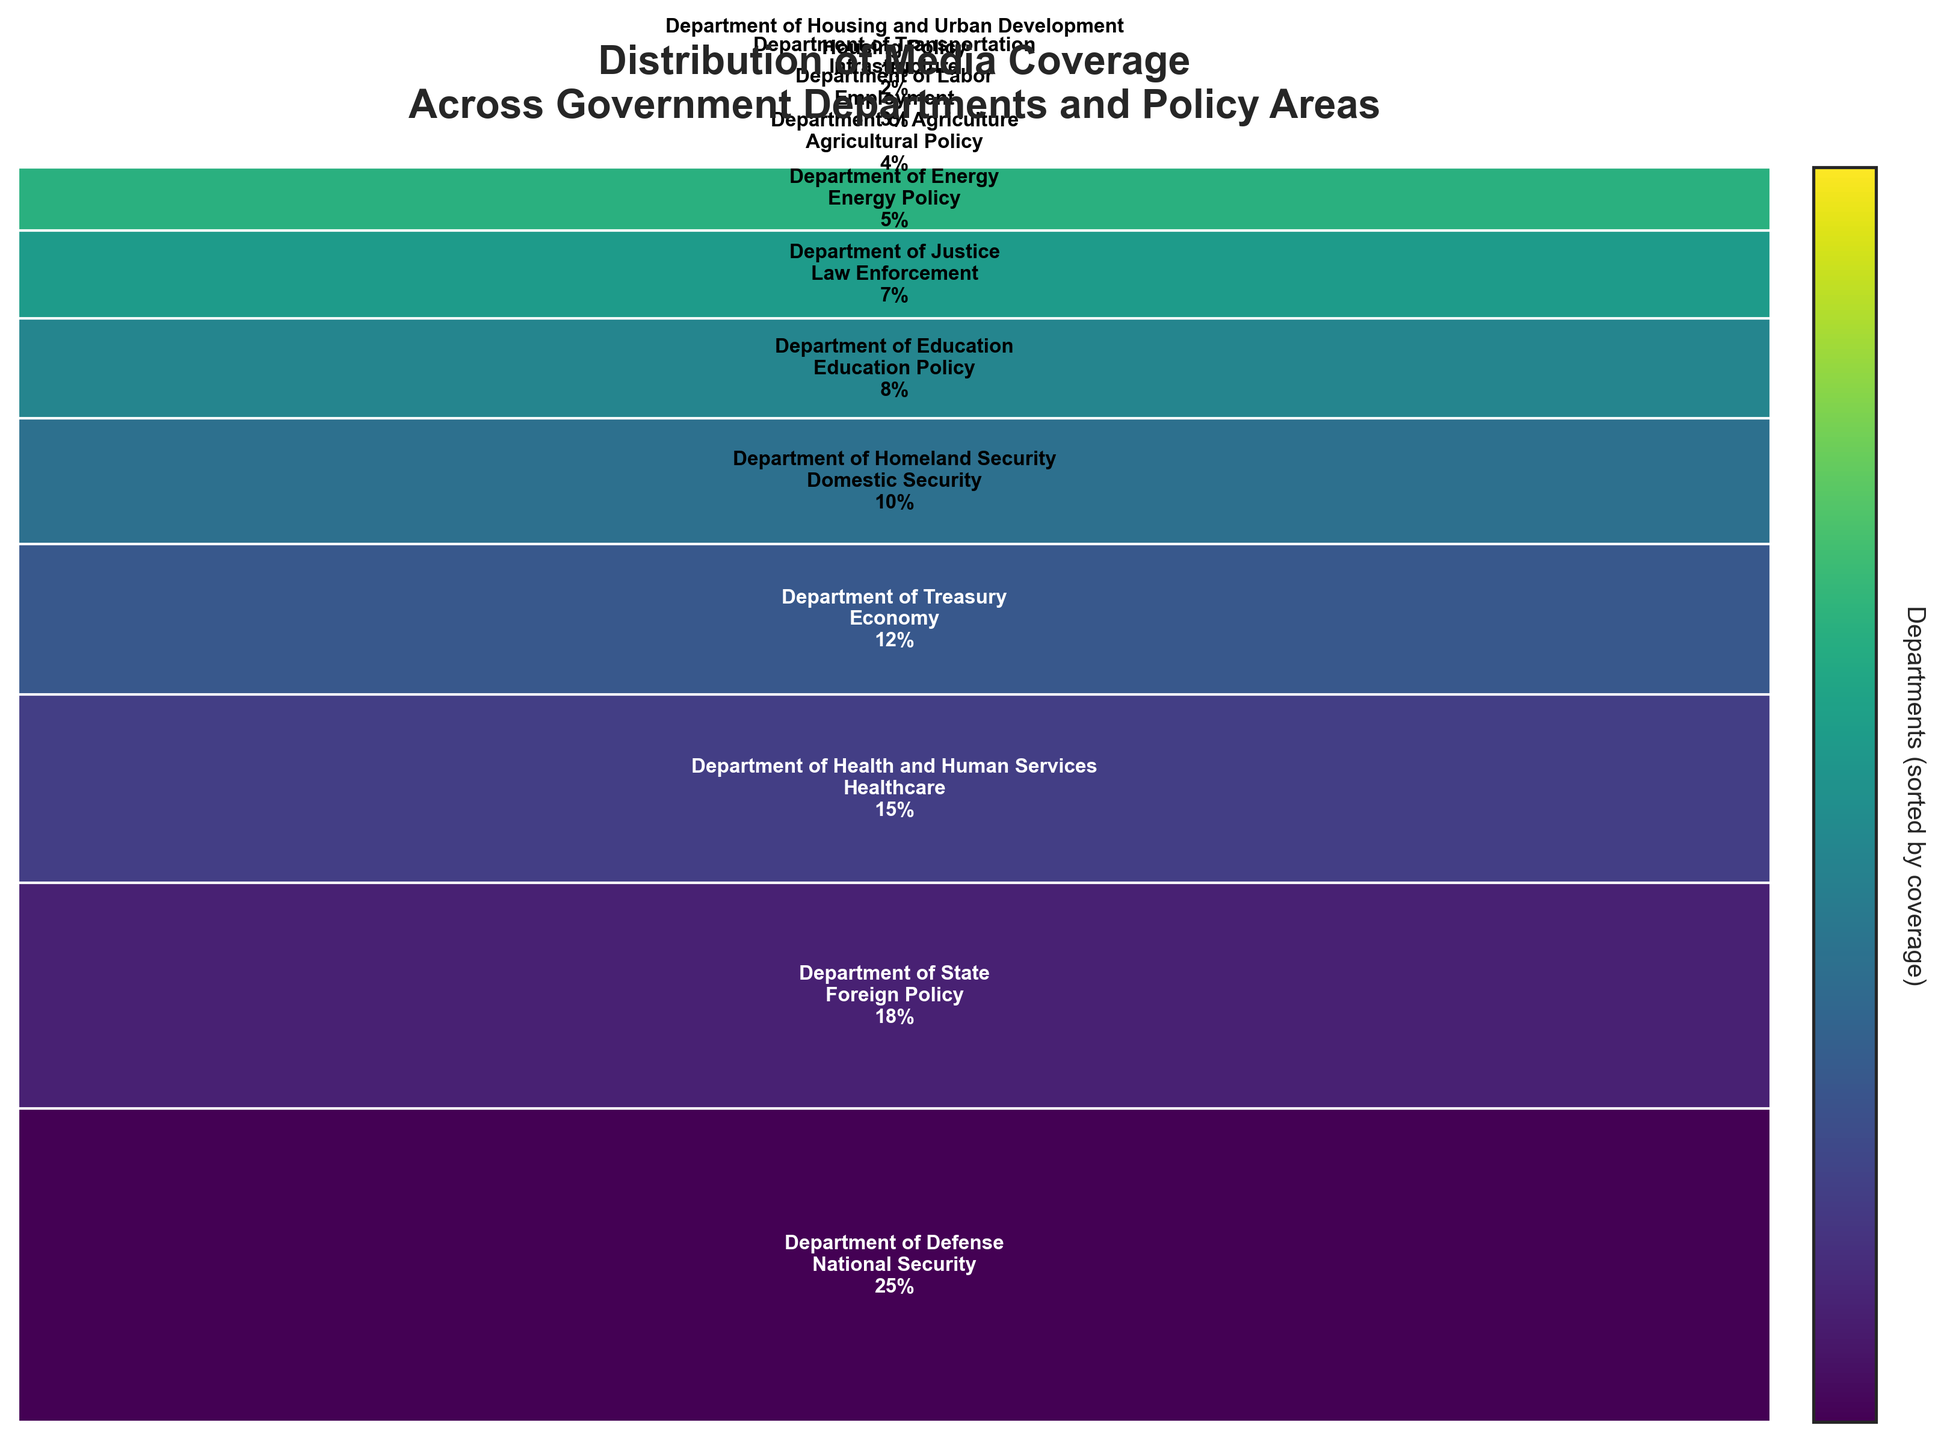What is the title of the figure? The title is usually placed at the top of the figure and describes the overall theme or subject of the plot.
Answer: Distribution of Media Coverage Across Government Departments and Policy Areas Which department has the highest media coverage? The department with the highest media coverage will have the largest rectangle at the top of the mosaic plot.
Answer: Department of Defense What percentage of media coverage does the Department of Education have? Each rectangle in the mosaic plot is labeled with its department, policy area, and coverage percentage. Look for the label "Department of Education" to find its coverage percentage.
Answer: 8% Which departments have less than 5% media coverage? Look at the rectangles in the mosaic plot and identify those with a coverage percentage of less than 5%.
Answer: Department of Agriculture, Department of Labor, Department of Transportation, Department of Housing and Urban Development What is the cumulative coverage percentage of the top 3 departments? To find the cumulative coverage percentage, add the coverage percentages of the top 3 departments from the plot.
Answer: 58% (25% + 18% + 15%) Compare the media coverage between the Department of Treasury and the Department of Homeland Security. Which one has higher coverage? Compare the coverage percentages of the Department of Treasury and the Department of Homeland Security from their respective rectangles.
Answer: Department of Treasury (12%) vs. Department of Homeland Security (10%). Department of Treasury has higher coverage Which policy area receives the lowest media coverage? The rectangle with the smallest area and the lowest percentage label indicates the policy area with the lowest media coverage.
Answer: Housing Policy What is the combined media coverage percentage of departments involved in security (both national and domestic)? Combine the media coverage percentages of the Department of Defense (National Security) and the Department of Homeland Security (Domestic Security).
Answer: 35% (25% + 10%) How does the media coverage of the Department of Energy compare to the Department of Justice? Look at the respective coverage percentages for the Department of Energy and the Department of Justice in the mosaic plot.
Answer: Department of Energy (5%) vs. Department of Justice (7%). Department of Justice has higher coverage What percentage of media coverage is attributed to Economic and Foreign Policy areas combined? Add the coverage percentages of the Department of Treasury (Economy) and the Department of State (Foreign Policy).
Answer: 30% (12% + 18%) 